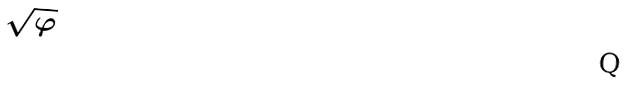<formula> <loc_0><loc_0><loc_500><loc_500>\sqrt { \varphi }</formula> 